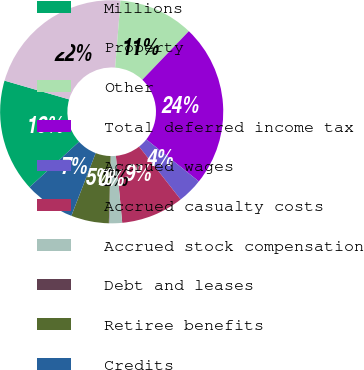<chart> <loc_0><loc_0><loc_500><loc_500><pie_chart><fcel>Millions<fcel>Property<fcel>Other<fcel>Total deferred income tax<fcel>Accrued wages<fcel>Accrued casualty costs<fcel>Accrued stock compensation<fcel>Debt and leases<fcel>Retiree benefits<fcel>Credits<nl><fcel>16.33%<fcel>21.76%<fcel>10.9%<fcel>23.57%<fcel>3.67%<fcel>9.1%<fcel>1.86%<fcel>0.05%<fcel>5.48%<fcel>7.29%<nl></chart> 